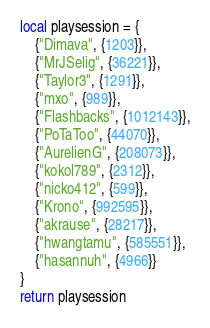<code> <loc_0><loc_0><loc_500><loc_500><_Lua_>local playsession = {
	{"Dimava", {1203}},
	{"MrJSelig", {36221}},
	{"Taylor3", {1291}},
	{"mxo", {989}},
	{"Flashbacks", {1012143}},
	{"PoTaToo", {44070}},
	{"AurelienG", {208073}},
	{"kokol789", {2312}},
	{"nicko412", {599}},
	{"Krono", {992595}},
	{"akrause", {28217}},
	{"hwangtamu", {585551}},
	{"hasannuh", {4966}}
}
return playsession</code> 